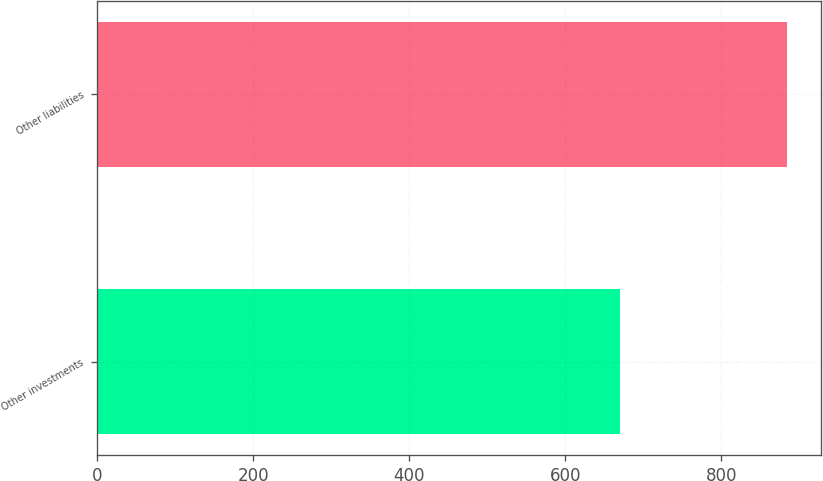Convert chart. <chart><loc_0><loc_0><loc_500><loc_500><bar_chart><fcel>Other investments<fcel>Other liabilities<nl><fcel>670<fcel>884<nl></chart> 